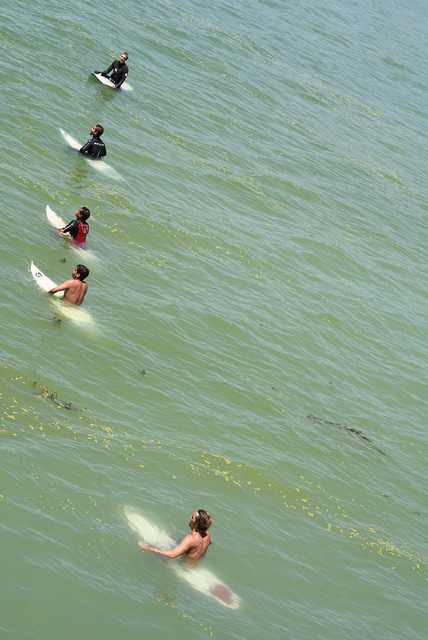How many surfboards are on the water? There are three surfboards visible on the water, with each one being steadily managed by respective surfers. 